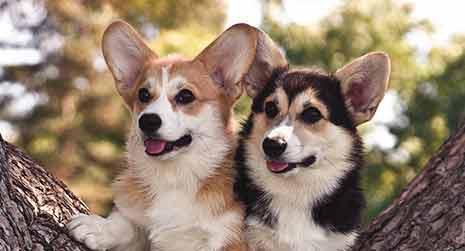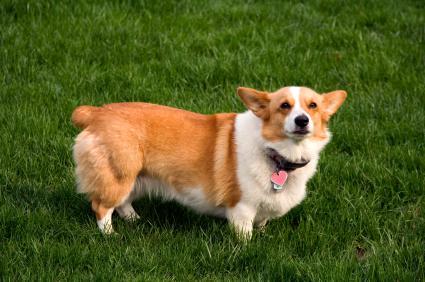The first image is the image on the left, the second image is the image on the right. For the images shown, is this caption "The dog in the image on the left is standing in the grass on all four legs." true? Answer yes or no. No. The first image is the image on the left, the second image is the image on the right. Examine the images to the left and right. Is the description "An image shows a corgi dog moving across the grass, with one front paw raised." accurate? Answer yes or no. No. 